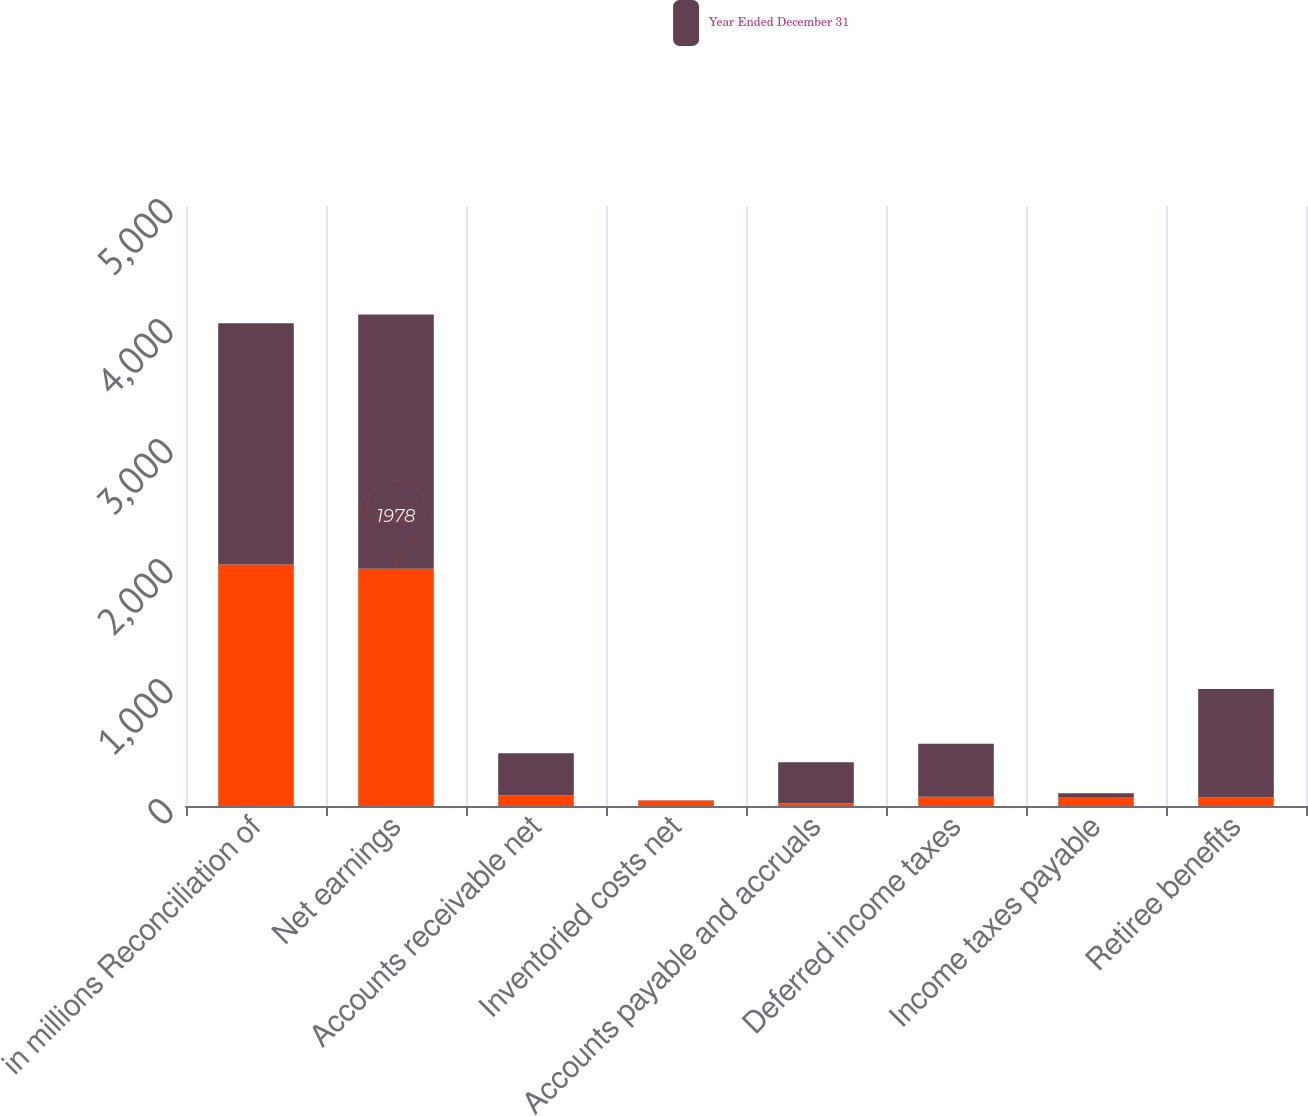Convert chart. <chart><loc_0><loc_0><loc_500><loc_500><stacked_bar_chart><ecel><fcel>in millions Reconciliation of<fcel>Net earnings<fcel>Accounts receivable net<fcel>Inventoried costs net<fcel>Accounts payable and accruals<fcel>Deferred income taxes<fcel>Income taxes payable<fcel>Retiree benefits<nl><fcel>nan<fcel>2012<fcel>1978<fcel>90<fcel>46<fcel>23<fcel>78<fcel>75<fcel>71<nl><fcel>Year Ended December 31<fcel>2011<fcel>2118<fcel>350<fcel>2<fcel>341<fcel>441<fcel>32<fcel>904<nl></chart> 